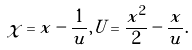<formula> <loc_0><loc_0><loc_500><loc_500>\tilde { \chi } = x - \frac { 1 } { u } , \tilde { U } = \frac { x ^ { 2 } } { 2 } - \frac { x } { u } .</formula> 